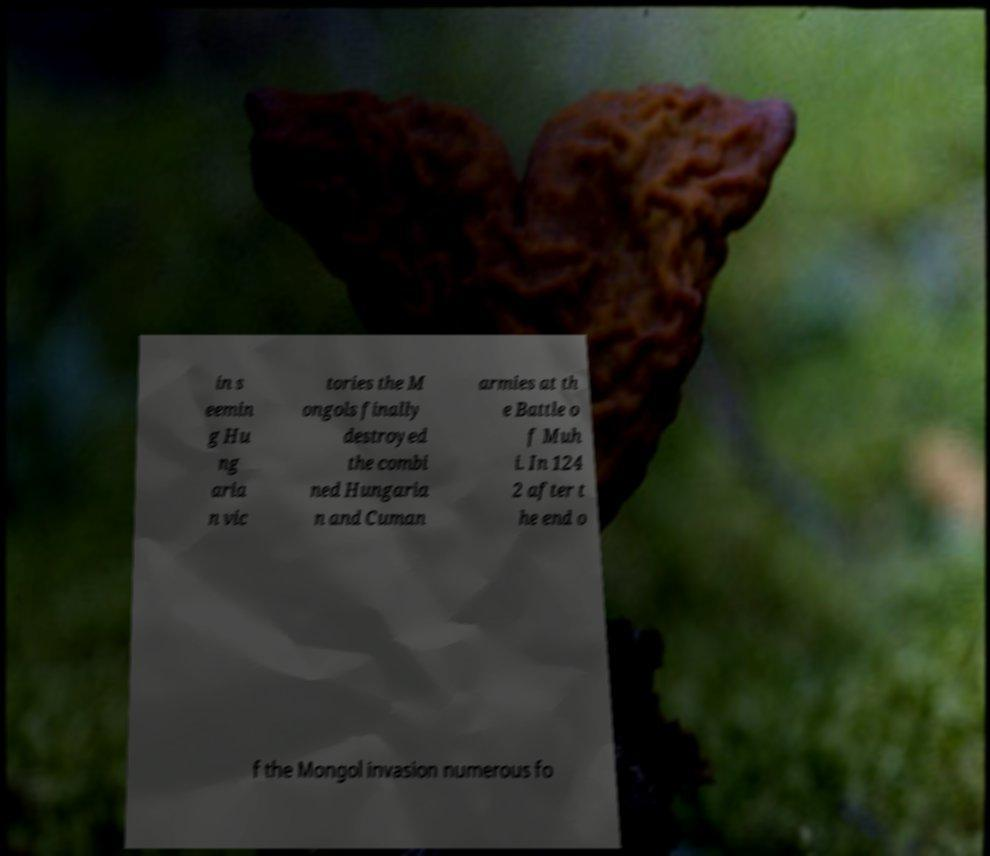Can you read and provide the text displayed in the image?This photo seems to have some interesting text. Can you extract and type it out for me? in s eemin g Hu ng aria n vic tories the M ongols finally destroyed the combi ned Hungaria n and Cuman armies at th e Battle o f Muh i. In 124 2 after t he end o f the Mongol invasion numerous fo 